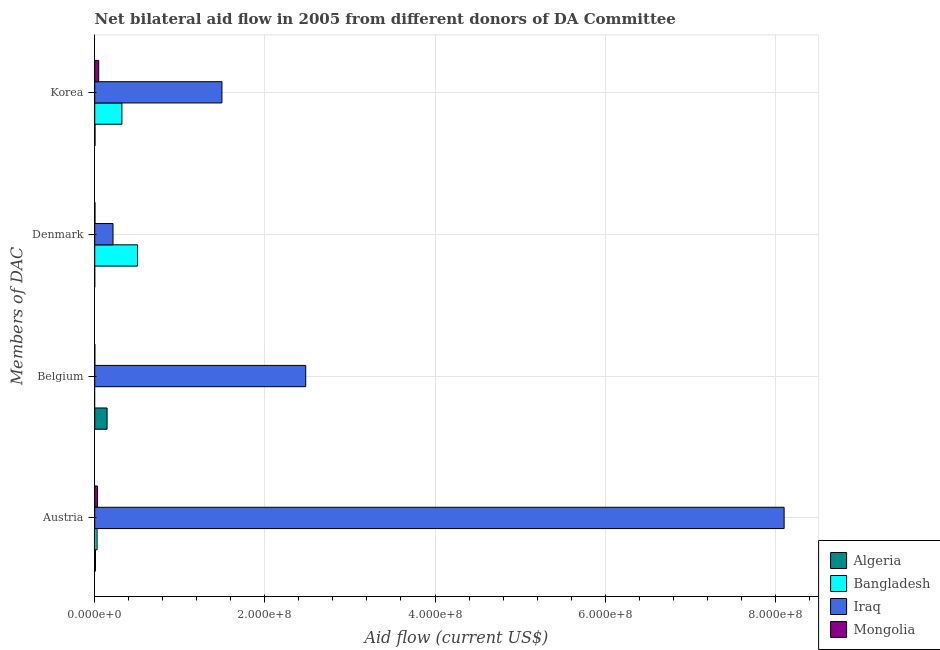How many different coloured bars are there?
Provide a short and direct response. 4. How many groups of bars are there?
Provide a short and direct response. 4. Are the number of bars per tick equal to the number of legend labels?
Make the answer very short. No. Are the number of bars on each tick of the Y-axis equal?
Offer a terse response. No. How many bars are there on the 1st tick from the top?
Your answer should be compact. 4. How many bars are there on the 2nd tick from the bottom?
Keep it short and to the point. 3. What is the label of the 4th group of bars from the top?
Provide a short and direct response. Austria. What is the amount of aid given by austria in Mongolia?
Ensure brevity in your answer.  3.26e+06. Across all countries, what is the maximum amount of aid given by austria?
Offer a terse response. 8.10e+08. Across all countries, what is the minimum amount of aid given by belgium?
Your answer should be very brief. 0. What is the total amount of aid given by denmark in the graph?
Your answer should be very brief. 7.21e+07. What is the difference between the amount of aid given by korea in Algeria and that in Mongolia?
Offer a very short reply. -4.32e+06. What is the difference between the amount of aid given by belgium in Algeria and the amount of aid given by austria in Iraq?
Your answer should be very brief. -7.96e+08. What is the average amount of aid given by austria per country?
Give a very brief answer. 2.04e+08. What is the difference between the amount of aid given by belgium and amount of aid given by austria in Mongolia?
Give a very brief answer. -3.15e+06. In how many countries, is the amount of aid given by austria greater than 600000000 US$?
Ensure brevity in your answer.  1. What is the ratio of the amount of aid given by korea in Algeria to that in Bangladesh?
Your answer should be compact. 0.01. Is the difference between the amount of aid given by korea in Bangladesh and Mongolia greater than the difference between the amount of aid given by denmark in Bangladesh and Mongolia?
Ensure brevity in your answer.  No. What is the difference between the highest and the second highest amount of aid given by denmark?
Offer a terse response. 2.89e+07. What is the difference between the highest and the lowest amount of aid given by belgium?
Provide a short and direct response. 2.48e+08. Is it the case that in every country, the sum of the amount of aid given by austria and amount of aid given by korea is greater than the sum of amount of aid given by denmark and amount of aid given by belgium?
Keep it short and to the point. No. Is it the case that in every country, the sum of the amount of aid given by austria and amount of aid given by belgium is greater than the amount of aid given by denmark?
Provide a succinct answer. No. How many bars are there?
Keep it short and to the point. 14. What is the difference between two consecutive major ticks on the X-axis?
Provide a short and direct response. 2.00e+08. Are the values on the major ticks of X-axis written in scientific E-notation?
Keep it short and to the point. Yes. Does the graph contain any zero values?
Offer a terse response. Yes. Does the graph contain grids?
Your answer should be compact. Yes. Where does the legend appear in the graph?
Keep it short and to the point. Bottom right. How are the legend labels stacked?
Your answer should be compact. Vertical. What is the title of the graph?
Your answer should be compact. Net bilateral aid flow in 2005 from different donors of DA Committee. Does "Barbados" appear as one of the legend labels in the graph?
Offer a terse response. No. What is the label or title of the Y-axis?
Your answer should be very brief. Members of DAC. What is the Aid flow (current US$) in Algeria in Austria?
Offer a terse response. 8.80e+05. What is the Aid flow (current US$) in Bangladesh in Austria?
Provide a succinct answer. 2.75e+06. What is the Aid flow (current US$) in Iraq in Austria?
Keep it short and to the point. 8.10e+08. What is the Aid flow (current US$) of Mongolia in Austria?
Offer a terse response. 3.26e+06. What is the Aid flow (current US$) in Algeria in Belgium?
Your answer should be very brief. 1.45e+07. What is the Aid flow (current US$) in Bangladesh in Belgium?
Give a very brief answer. 0. What is the Aid flow (current US$) in Iraq in Belgium?
Give a very brief answer. 2.48e+08. What is the Aid flow (current US$) in Mongolia in Belgium?
Your answer should be compact. 1.10e+05. What is the Aid flow (current US$) of Algeria in Denmark?
Provide a succinct answer. 0. What is the Aid flow (current US$) of Bangladesh in Denmark?
Your answer should be very brief. 5.04e+07. What is the Aid flow (current US$) of Iraq in Denmark?
Make the answer very short. 2.15e+07. What is the Aid flow (current US$) in Bangladesh in Korea?
Your response must be concise. 3.19e+07. What is the Aid flow (current US$) in Iraq in Korea?
Provide a succinct answer. 1.50e+08. What is the Aid flow (current US$) of Mongolia in Korea?
Your answer should be compact. 4.66e+06. Across all Members of DAC, what is the maximum Aid flow (current US$) in Algeria?
Your response must be concise. 1.45e+07. Across all Members of DAC, what is the maximum Aid flow (current US$) of Bangladesh?
Make the answer very short. 5.04e+07. Across all Members of DAC, what is the maximum Aid flow (current US$) of Iraq?
Make the answer very short. 8.10e+08. Across all Members of DAC, what is the maximum Aid flow (current US$) of Mongolia?
Offer a terse response. 4.66e+06. Across all Members of DAC, what is the minimum Aid flow (current US$) in Algeria?
Offer a terse response. 0. Across all Members of DAC, what is the minimum Aid flow (current US$) in Iraq?
Your answer should be very brief. 2.15e+07. What is the total Aid flow (current US$) of Algeria in the graph?
Your answer should be very brief. 1.57e+07. What is the total Aid flow (current US$) in Bangladesh in the graph?
Keep it short and to the point. 8.50e+07. What is the total Aid flow (current US$) of Iraq in the graph?
Offer a very short reply. 1.23e+09. What is the total Aid flow (current US$) of Mongolia in the graph?
Provide a short and direct response. 8.31e+06. What is the difference between the Aid flow (current US$) of Algeria in Austria and that in Belgium?
Your answer should be very brief. -1.36e+07. What is the difference between the Aid flow (current US$) of Iraq in Austria and that in Belgium?
Your response must be concise. 5.62e+08. What is the difference between the Aid flow (current US$) in Mongolia in Austria and that in Belgium?
Your answer should be very brief. 3.15e+06. What is the difference between the Aid flow (current US$) of Bangladesh in Austria and that in Denmark?
Your answer should be compact. -4.76e+07. What is the difference between the Aid flow (current US$) of Iraq in Austria and that in Denmark?
Make the answer very short. 7.89e+08. What is the difference between the Aid flow (current US$) of Mongolia in Austria and that in Denmark?
Provide a succinct answer. 2.98e+06. What is the difference between the Aid flow (current US$) in Algeria in Austria and that in Korea?
Your answer should be very brief. 5.40e+05. What is the difference between the Aid flow (current US$) in Bangladesh in Austria and that in Korea?
Your response must be concise. -2.92e+07. What is the difference between the Aid flow (current US$) in Iraq in Austria and that in Korea?
Give a very brief answer. 6.61e+08. What is the difference between the Aid flow (current US$) in Mongolia in Austria and that in Korea?
Offer a very short reply. -1.40e+06. What is the difference between the Aid flow (current US$) of Iraq in Belgium and that in Denmark?
Provide a short and direct response. 2.27e+08. What is the difference between the Aid flow (current US$) of Algeria in Belgium and that in Korea?
Make the answer very short. 1.42e+07. What is the difference between the Aid flow (current US$) in Iraq in Belgium and that in Korea?
Offer a very short reply. 9.85e+07. What is the difference between the Aid flow (current US$) of Mongolia in Belgium and that in Korea?
Ensure brevity in your answer.  -4.55e+06. What is the difference between the Aid flow (current US$) of Bangladesh in Denmark and that in Korea?
Your answer should be very brief. 1.84e+07. What is the difference between the Aid flow (current US$) in Iraq in Denmark and that in Korea?
Make the answer very short. -1.28e+08. What is the difference between the Aid flow (current US$) of Mongolia in Denmark and that in Korea?
Provide a succinct answer. -4.38e+06. What is the difference between the Aid flow (current US$) in Algeria in Austria and the Aid flow (current US$) in Iraq in Belgium?
Your response must be concise. -2.47e+08. What is the difference between the Aid flow (current US$) of Algeria in Austria and the Aid flow (current US$) of Mongolia in Belgium?
Make the answer very short. 7.70e+05. What is the difference between the Aid flow (current US$) of Bangladesh in Austria and the Aid flow (current US$) of Iraq in Belgium?
Offer a terse response. -2.45e+08. What is the difference between the Aid flow (current US$) in Bangladesh in Austria and the Aid flow (current US$) in Mongolia in Belgium?
Provide a short and direct response. 2.64e+06. What is the difference between the Aid flow (current US$) in Iraq in Austria and the Aid flow (current US$) in Mongolia in Belgium?
Make the answer very short. 8.10e+08. What is the difference between the Aid flow (current US$) in Algeria in Austria and the Aid flow (current US$) in Bangladesh in Denmark?
Offer a terse response. -4.95e+07. What is the difference between the Aid flow (current US$) in Algeria in Austria and the Aid flow (current US$) in Iraq in Denmark?
Ensure brevity in your answer.  -2.06e+07. What is the difference between the Aid flow (current US$) of Algeria in Austria and the Aid flow (current US$) of Mongolia in Denmark?
Your response must be concise. 6.00e+05. What is the difference between the Aid flow (current US$) in Bangladesh in Austria and the Aid flow (current US$) in Iraq in Denmark?
Your answer should be very brief. -1.88e+07. What is the difference between the Aid flow (current US$) of Bangladesh in Austria and the Aid flow (current US$) of Mongolia in Denmark?
Keep it short and to the point. 2.47e+06. What is the difference between the Aid flow (current US$) of Iraq in Austria and the Aid flow (current US$) of Mongolia in Denmark?
Ensure brevity in your answer.  8.10e+08. What is the difference between the Aid flow (current US$) of Algeria in Austria and the Aid flow (current US$) of Bangladesh in Korea?
Your answer should be compact. -3.11e+07. What is the difference between the Aid flow (current US$) of Algeria in Austria and the Aid flow (current US$) of Iraq in Korea?
Keep it short and to the point. -1.49e+08. What is the difference between the Aid flow (current US$) of Algeria in Austria and the Aid flow (current US$) of Mongolia in Korea?
Ensure brevity in your answer.  -3.78e+06. What is the difference between the Aid flow (current US$) of Bangladesh in Austria and the Aid flow (current US$) of Iraq in Korea?
Ensure brevity in your answer.  -1.47e+08. What is the difference between the Aid flow (current US$) of Bangladesh in Austria and the Aid flow (current US$) of Mongolia in Korea?
Your answer should be very brief. -1.91e+06. What is the difference between the Aid flow (current US$) of Iraq in Austria and the Aid flow (current US$) of Mongolia in Korea?
Your answer should be very brief. 8.06e+08. What is the difference between the Aid flow (current US$) of Algeria in Belgium and the Aid flow (current US$) of Bangladesh in Denmark?
Your answer should be very brief. -3.58e+07. What is the difference between the Aid flow (current US$) in Algeria in Belgium and the Aid flow (current US$) in Iraq in Denmark?
Offer a terse response. -6.99e+06. What is the difference between the Aid flow (current US$) in Algeria in Belgium and the Aid flow (current US$) in Mongolia in Denmark?
Ensure brevity in your answer.  1.42e+07. What is the difference between the Aid flow (current US$) in Iraq in Belgium and the Aid flow (current US$) in Mongolia in Denmark?
Keep it short and to the point. 2.48e+08. What is the difference between the Aid flow (current US$) of Algeria in Belgium and the Aid flow (current US$) of Bangladesh in Korea?
Your answer should be compact. -1.74e+07. What is the difference between the Aid flow (current US$) in Algeria in Belgium and the Aid flow (current US$) in Iraq in Korea?
Your response must be concise. -1.35e+08. What is the difference between the Aid flow (current US$) in Algeria in Belgium and the Aid flow (current US$) in Mongolia in Korea?
Ensure brevity in your answer.  9.85e+06. What is the difference between the Aid flow (current US$) in Iraq in Belgium and the Aid flow (current US$) in Mongolia in Korea?
Ensure brevity in your answer.  2.43e+08. What is the difference between the Aid flow (current US$) in Bangladesh in Denmark and the Aid flow (current US$) in Iraq in Korea?
Your response must be concise. -9.92e+07. What is the difference between the Aid flow (current US$) of Bangladesh in Denmark and the Aid flow (current US$) of Mongolia in Korea?
Your answer should be compact. 4.57e+07. What is the difference between the Aid flow (current US$) in Iraq in Denmark and the Aid flow (current US$) in Mongolia in Korea?
Your answer should be very brief. 1.68e+07. What is the average Aid flow (current US$) of Algeria per Members of DAC?
Offer a very short reply. 3.93e+06. What is the average Aid flow (current US$) in Bangladesh per Members of DAC?
Your answer should be compact. 2.13e+07. What is the average Aid flow (current US$) in Iraq per Members of DAC?
Give a very brief answer. 3.07e+08. What is the average Aid flow (current US$) in Mongolia per Members of DAC?
Your answer should be compact. 2.08e+06. What is the difference between the Aid flow (current US$) in Algeria and Aid flow (current US$) in Bangladesh in Austria?
Give a very brief answer. -1.87e+06. What is the difference between the Aid flow (current US$) in Algeria and Aid flow (current US$) in Iraq in Austria?
Make the answer very short. -8.10e+08. What is the difference between the Aid flow (current US$) of Algeria and Aid flow (current US$) of Mongolia in Austria?
Ensure brevity in your answer.  -2.38e+06. What is the difference between the Aid flow (current US$) of Bangladesh and Aid flow (current US$) of Iraq in Austria?
Your answer should be very brief. -8.08e+08. What is the difference between the Aid flow (current US$) in Bangladesh and Aid flow (current US$) in Mongolia in Austria?
Keep it short and to the point. -5.10e+05. What is the difference between the Aid flow (current US$) in Iraq and Aid flow (current US$) in Mongolia in Austria?
Make the answer very short. 8.07e+08. What is the difference between the Aid flow (current US$) in Algeria and Aid flow (current US$) in Iraq in Belgium?
Make the answer very short. -2.34e+08. What is the difference between the Aid flow (current US$) of Algeria and Aid flow (current US$) of Mongolia in Belgium?
Provide a succinct answer. 1.44e+07. What is the difference between the Aid flow (current US$) in Iraq and Aid flow (current US$) in Mongolia in Belgium?
Your response must be concise. 2.48e+08. What is the difference between the Aid flow (current US$) in Bangladesh and Aid flow (current US$) in Iraq in Denmark?
Your answer should be very brief. 2.89e+07. What is the difference between the Aid flow (current US$) of Bangladesh and Aid flow (current US$) of Mongolia in Denmark?
Provide a succinct answer. 5.01e+07. What is the difference between the Aid flow (current US$) in Iraq and Aid flow (current US$) in Mongolia in Denmark?
Ensure brevity in your answer.  2.12e+07. What is the difference between the Aid flow (current US$) in Algeria and Aid flow (current US$) in Bangladesh in Korea?
Your response must be concise. -3.16e+07. What is the difference between the Aid flow (current US$) of Algeria and Aid flow (current US$) of Iraq in Korea?
Provide a short and direct response. -1.49e+08. What is the difference between the Aid flow (current US$) of Algeria and Aid flow (current US$) of Mongolia in Korea?
Offer a terse response. -4.32e+06. What is the difference between the Aid flow (current US$) in Bangladesh and Aid flow (current US$) in Iraq in Korea?
Provide a succinct answer. -1.18e+08. What is the difference between the Aid flow (current US$) of Bangladesh and Aid flow (current US$) of Mongolia in Korea?
Make the answer very short. 2.73e+07. What is the difference between the Aid flow (current US$) in Iraq and Aid flow (current US$) in Mongolia in Korea?
Provide a succinct answer. 1.45e+08. What is the ratio of the Aid flow (current US$) of Algeria in Austria to that in Belgium?
Provide a succinct answer. 0.06. What is the ratio of the Aid flow (current US$) in Iraq in Austria to that in Belgium?
Offer a very short reply. 3.27. What is the ratio of the Aid flow (current US$) in Mongolia in Austria to that in Belgium?
Your answer should be very brief. 29.64. What is the ratio of the Aid flow (current US$) in Bangladesh in Austria to that in Denmark?
Provide a succinct answer. 0.05. What is the ratio of the Aid flow (current US$) in Iraq in Austria to that in Denmark?
Your answer should be compact. 37.69. What is the ratio of the Aid flow (current US$) in Mongolia in Austria to that in Denmark?
Offer a very short reply. 11.64. What is the ratio of the Aid flow (current US$) in Algeria in Austria to that in Korea?
Provide a succinct answer. 2.59. What is the ratio of the Aid flow (current US$) of Bangladesh in Austria to that in Korea?
Make the answer very short. 0.09. What is the ratio of the Aid flow (current US$) in Iraq in Austria to that in Korea?
Give a very brief answer. 5.42. What is the ratio of the Aid flow (current US$) in Mongolia in Austria to that in Korea?
Keep it short and to the point. 0.7. What is the ratio of the Aid flow (current US$) of Iraq in Belgium to that in Denmark?
Offer a very short reply. 11.54. What is the ratio of the Aid flow (current US$) of Mongolia in Belgium to that in Denmark?
Provide a short and direct response. 0.39. What is the ratio of the Aid flow (current US$) of Algeria in Belgium to that in Korea?
Provide a short and direct response. 42.68. What is the ratio of the Aid flow (current US$) in Iraq in Belgium to that in Korea?
Your response must be concise. 1.66. What is the ratio of the Aid flow (current US$) of Mongolia in Belgium to that in Korea?
Your answer should be very brief. 0.02. What is the ratio of the Aid flow (current US$) in Bangladesh in Denmark to that in Korea?
Keep it short and to the point. 1.58. What is the ratio of the Aid flow (current US$) of Iraq in Denmark to that in Korea?
Your answer should be very brief. 0.14. What is the ratio of the Aid flow (current US$) of Mongolia in Denmark to that in Korea?
Ensure brevity in your answer.  0.06. What is the difference between the highest and the second highest Aid flow (current US$) of Algeria?
Your answer should be very brief. 1.36e+07. What is the difference between the highest and the second highest Aid flow (current US$) in Bangladesh?
Make the answer very short. 1.84e+07. What is the difference between the highest and the second highest Aid flow (current US$) of Iraq?
Your answer should be compact. 5.62e+08. What is the difference between the highest and the second highest Aid flow (current US$) of Mongolia?
Provide a short and direct response. 1.40e+06. What is the difference between the highest and the lowest Aid flow (current US$) in Algeria?
Make the answer very short. 1.45e+07. What is the difference between the highest and the lowest Aid flow (current US$) of Bangladesh?
Offer a very short reply. 5.04e+07. What is the difference between the highest and the lowest Aid flow (current US$) in Iraq?
Keep it short and to the point. 7.89e+08. What is the difference between the highest and the lowest Aid flow (current US$) in Mongolia?
Offer a terse response. 4.55e+06. 